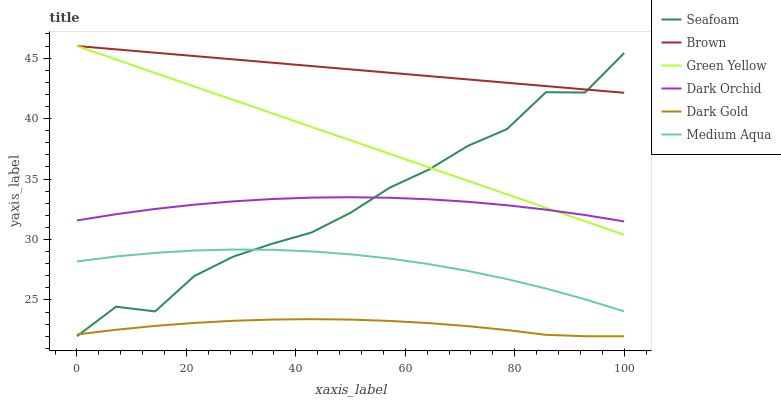Does Dark Gold have the minimum area under the curve?
Answer yes or no. Yes. Does Brown have the maximum area under the curve?
Answer yes or no. Yes. Does Seafoam have the minimum area under the curve?
Answer yes or no. No. Does Seafoam have the maximum area under the curve?
Answer yes or no. No. Is Brown the smoothest?
Answer yes or no. Yes. Is Seafoam the roughest?
Answer yes or no. Yes. Is Dark Gold the smoothest?
Answer yes or no. No. Is Dark Gold the roughest?
Answer yes or no. No. Does Dark Gold have the lowest value?
Answer yes or no. Yes. Does Dark Orchid have the lowest value?
Answer yes or no. No. Does Green Yellow have the highest value?
Answer yes or no. Yes. Does Seafoam have the highest value?
Answer yes or no. No. Is Dark Gold less than Brown?
Answer yes or no. Yes. Is Dark Orchid greater than Dark Gold?
Answer yes or no. Yes. Does Green Yellow intersect Brown?
Answer yes or no. Yes. Is Green Yellow less than Brown?
Answer yes or no. No. Is Green Yellow greater than Brown?
Answer yes or no. No. Does Dark Gold intersect Brown?
Answer yes or no. No. 